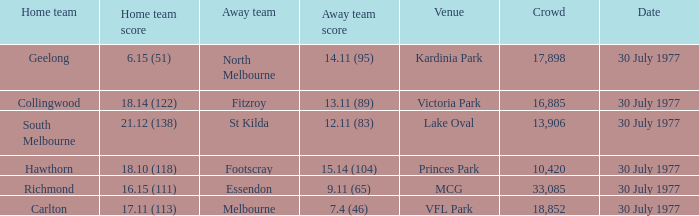What is north melbourne's score as a visiting team? 14.11 (95). 